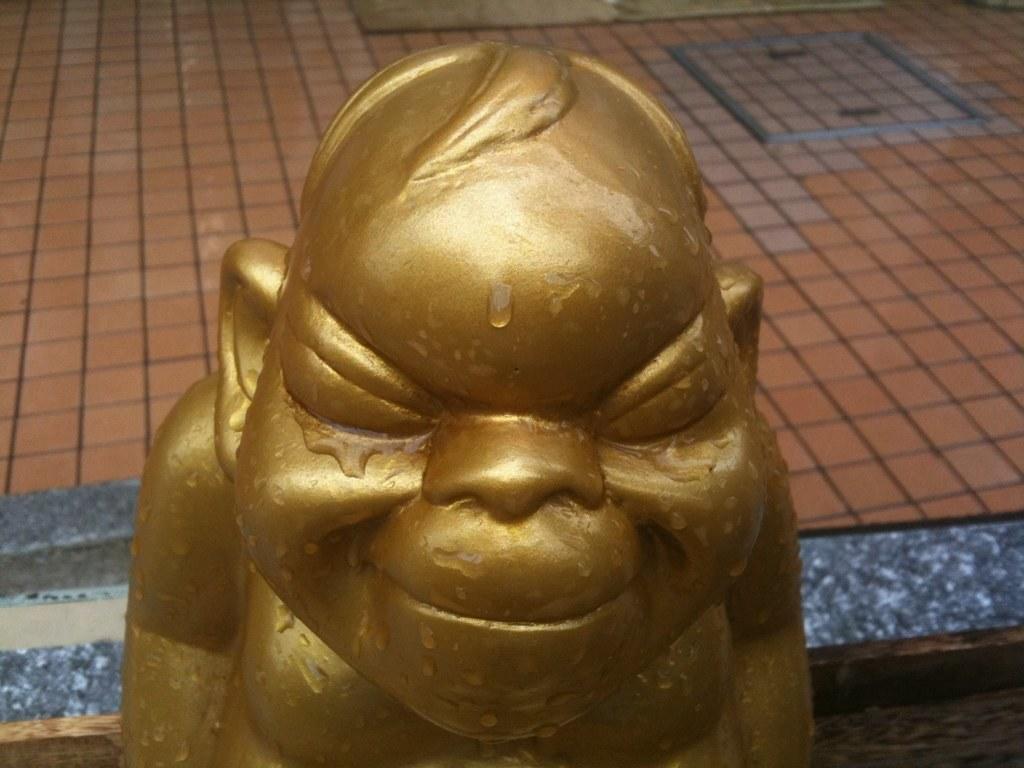Can you describe this image briefly? There is a laughing Buddha with water on that. In the back there is a floor. 